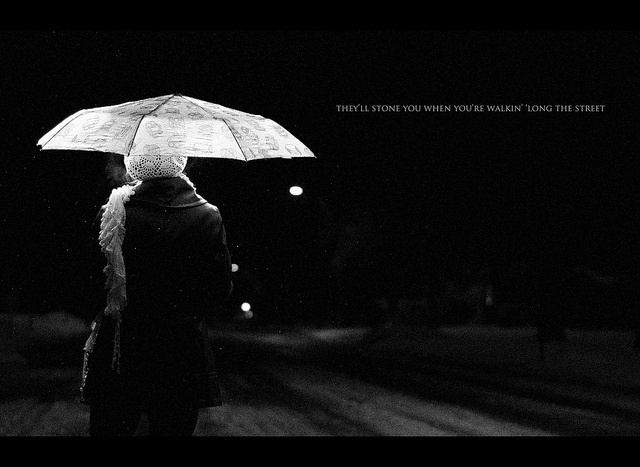Describe the objects in this image and their specific colors. I can see people in black, gray, darkgray, and lightgray tones and umbrella in black, lightgray, darkgray, and gray tones in this image. 